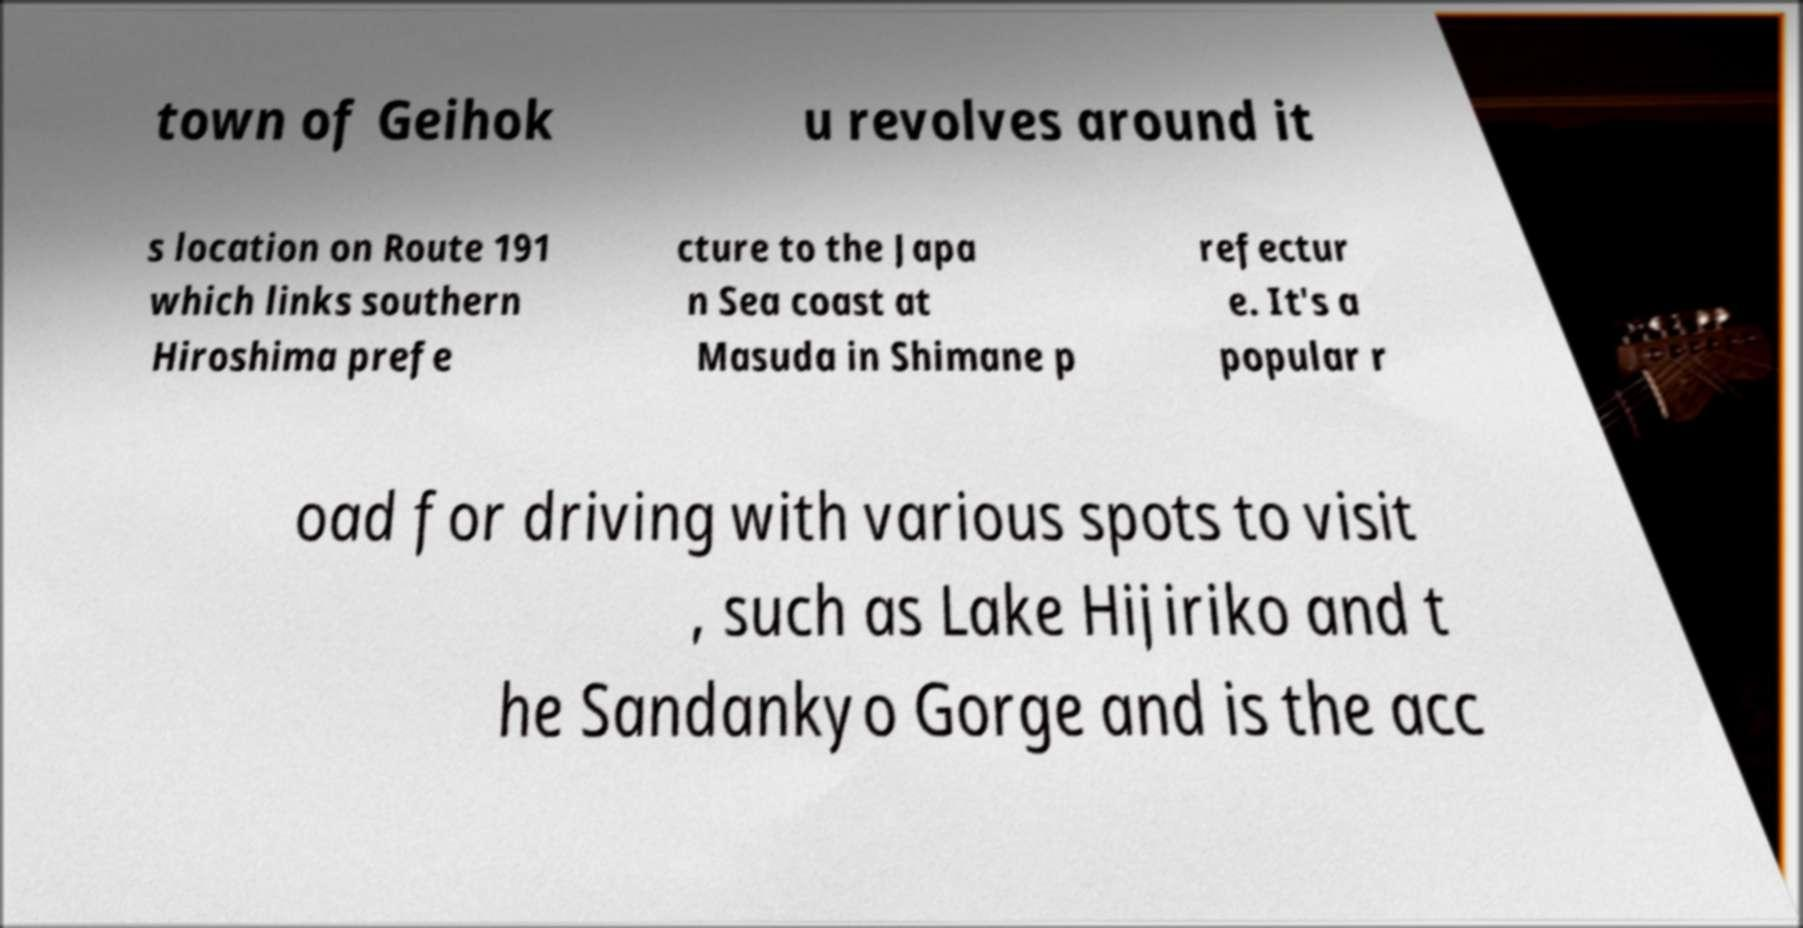I need the written content from this picture converted into text. Can you do that? town of Geihok u revolves around it s location on Route 191 which links southern Hiroshima prefe cture to the Japa n Sea coast at Masuda in Shimane p refectur e. It's a popular r oad for driving with various spots to visit , such as Lake Hijiriko and t he Sandankyo Gorge and is the acc 